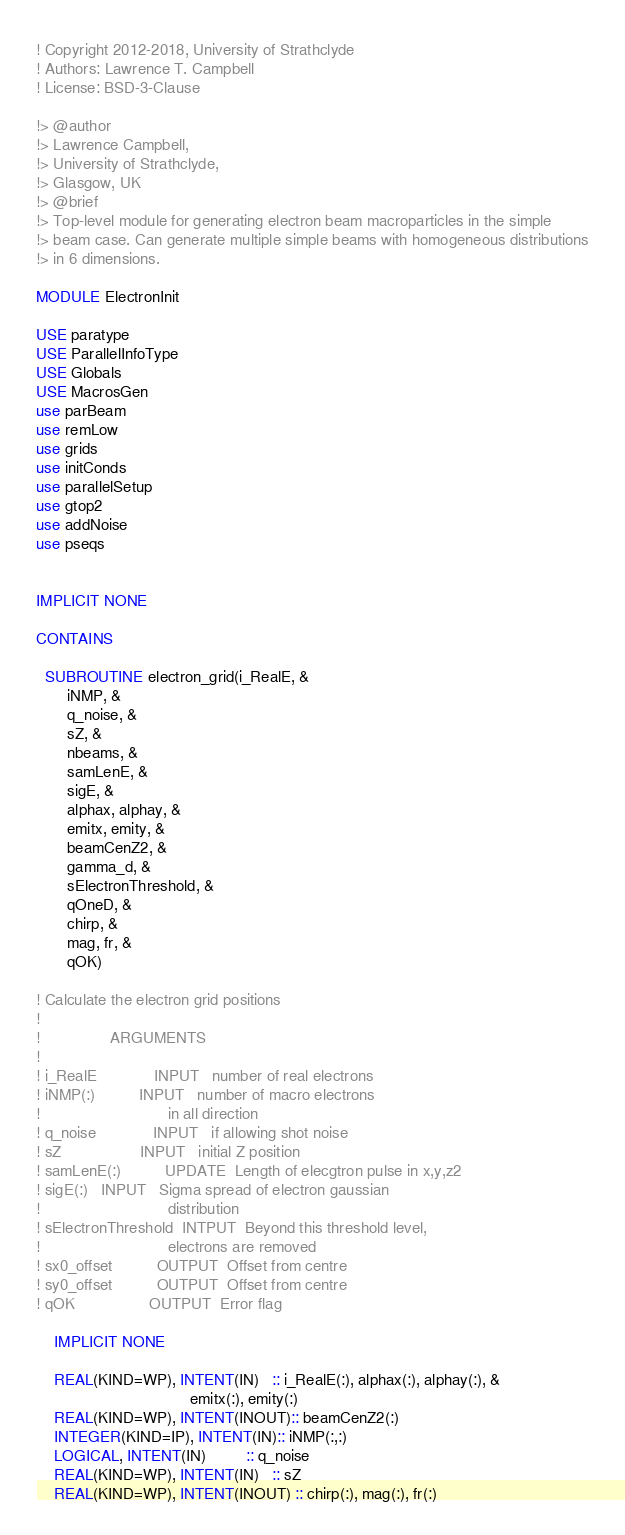<code> <loc_0><loc_0><loc_500><loc_500><_FORTRAN_>! Copyright 2012-2018, University of Strathclyde
! Authors: Lawrence T. Campbell
! License: BSD-3-Clause

!> @author
!> Lawrence Campbell,
!> University of Strathclyde, 
!> Glasgow, UK
!> @brief
!> Top-level module for generating electron beam macroparticles in the simple
!> beam case. Can generate multiple simple beams with homogeneous distributions
!> in 6 dimensions.

MODULE ElectronInit

USE paratype
USE ParallelInfoType
USE Globals
USE MacrosGen
use parBeam
use remLow
use grids
use initConds
use parallelSetup
use gtop2
use addNoise
use pseqs


IMPLICIT NONE

CONTAINS

  SUBROUTINE electron_grid(i_RealE, &
       iNMP, &
       q_noise, &
       sZ, &
       nbeams, &
       samLenE, &
       sigE, &
       alphax, alphay, &
       emitx, emity, &
       beamCenZ2, &
       gamma_d, &
       sElectronThreshold, &
       qOneD, &
       chirp, &
       mag, fr, &
       qOK)

! Calculate the electron grid positions
!
!                ARGUMENTS
!
! i_RealE             INPUT   number of real electrons
! iNMP(:)          INPUT   number of macro electrons
!                             in all direction
! q_noise             INPUT   if allowing shot noise
! sZ                  INPUT   initial Z position
! samLenE(:)	      UPDATE  Length of elecgtron pulse in x,y,z2
! sigE(:)   INPUT   Sigma spread of electron gaussian
!                             distribution
! sElectronThreshold  INTPUT  Beyond this threshold level,
!                             electrons are removed
! sx0_offset          OUTPUT  Offset from centre
! sy0_offset          OUTPUT  Offset from centre
! qOK                 OUTPUT  Error flag

    IMPLICIT NONE

    REAL(KIND=WP), INTENT(IN)   :: i_RealE(:), alphax(:), alphay(:), &
                                   emitx(:), emity(:)
    REAL(KIND=WP), INTENT(INOUT):: beamCenZ2(:)
    INTEGER(KIND=IP), INTENT(IN):: iNMP(:,:)
    LOGICAL, INTENT(IN)         :: q_noise
    REAL(KIND=WP), INTENT(IN)   :: sZ
    REAL(KIND=WP), INTENT(INOUT) :: chirp(:), mag(:), fr(:)

</code> 